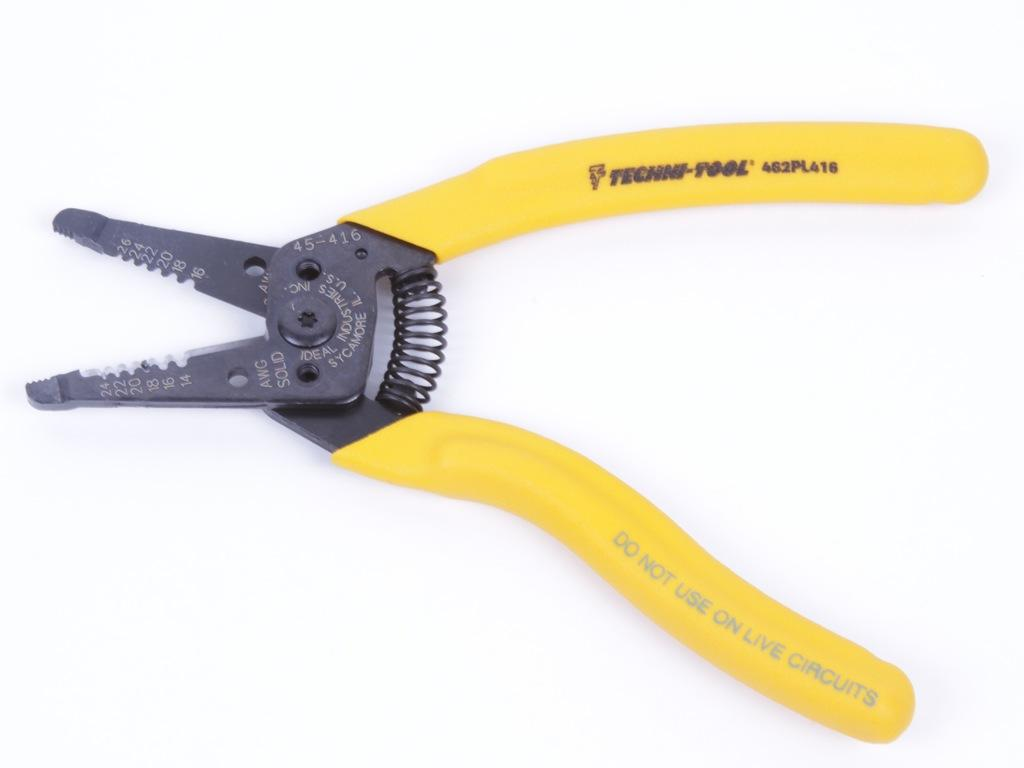<image>
Create a compact narrative representing the image presented. A yellow tool has a warning on the side of it not to use it on live electrical outlets. 